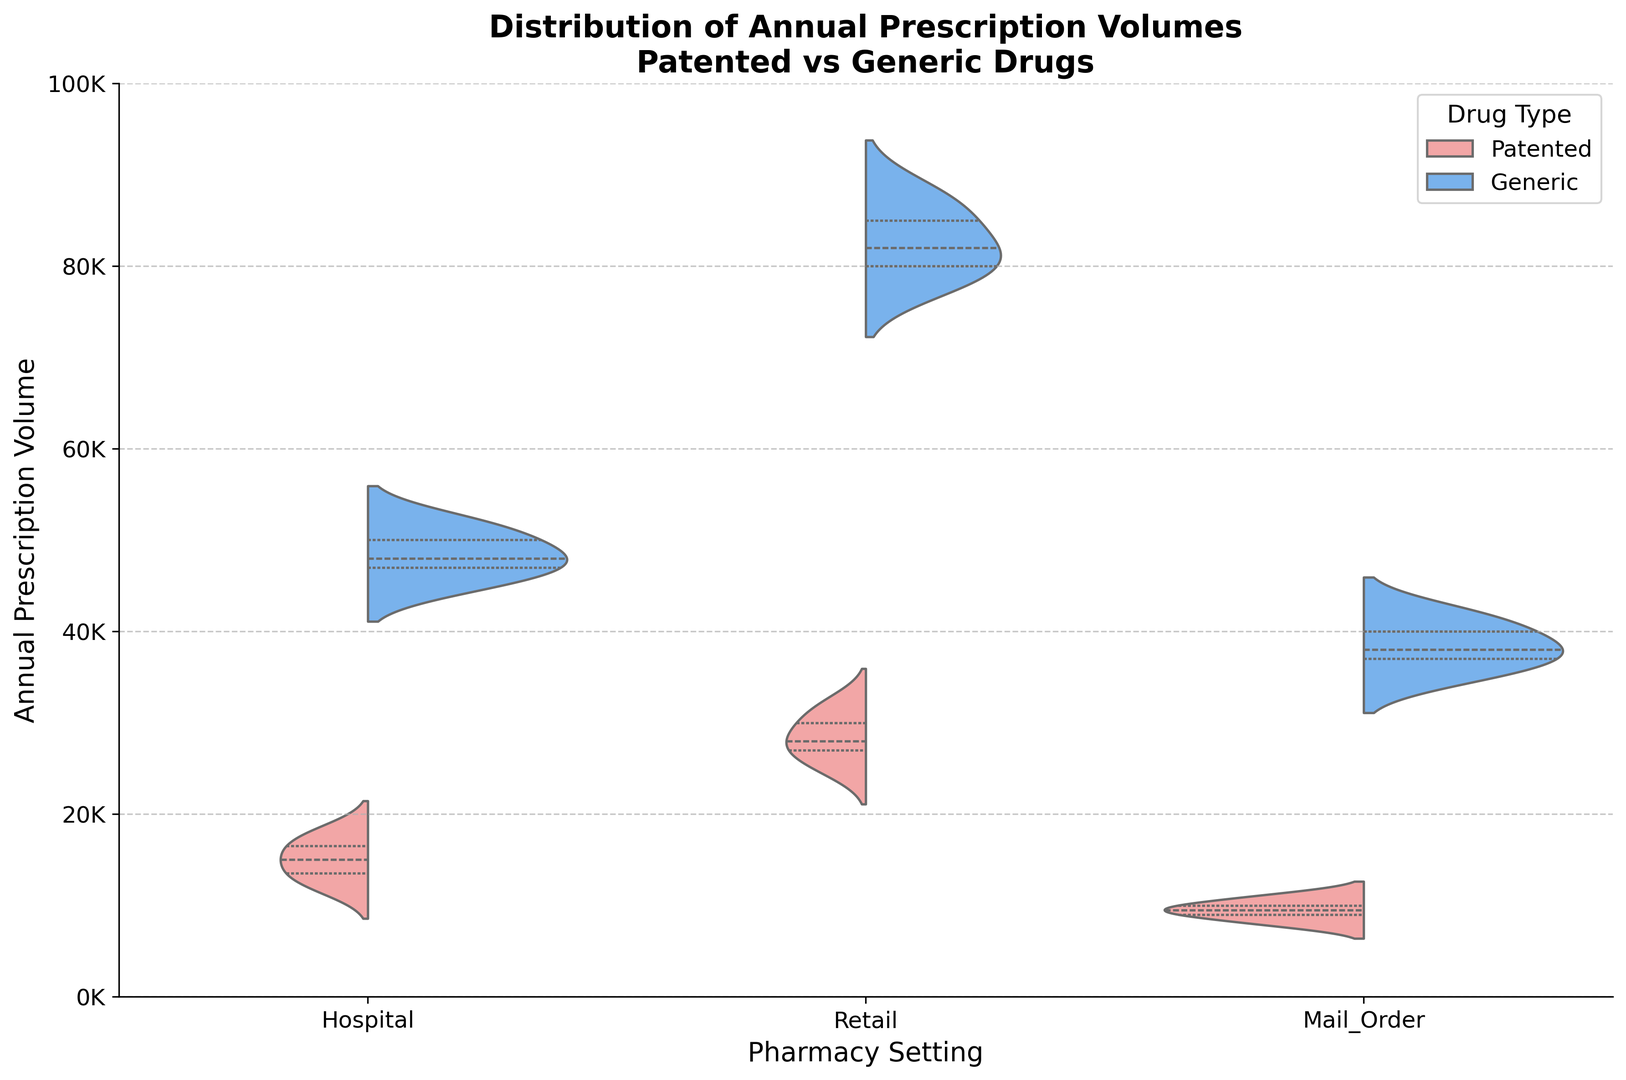What's the average annual prescription volume for patented drugs in retail settings? We observe that the annual prescription volumes for patented drugs in retail settings are 25000, 30000, 28000, 32000, and 27000. Adding them together gives 142000. Dividing by the number of data points (5), the average is 142000 / 5 = 28400
Answer: 28400 Which pharmacy setting has the highest median annual prescription volume for generic drugs? We compare the medians of the datasets for hospital, retail, and mail order pharmacy settings for generic drugs. The highest median is observed at retail settings.
Answer: Retail How does the average annual prescription volume for patented drugs compare between hospital and mail order settings? The average for hospital settings is calculated from (12000 + 15000 + 18000 + 13500 + 16500) / 5 = 15000. For mail order, it is (8000 + 10000 + 9500 + 11000 + 9000) / 5 = 9500. Therefore, the hospital setting has a higher average.
Answer: Hospital has a higher average What's the difference in the median annual prescription volume between patented and generic drugs in hospital settings? We find the median of patented drugs in hospital settings, which is 15000 (middle value of sorted data). For generic drugs, it's 48000 (middle value of sorted data). The difference is 48000 - 15000 = 33000.
Answer: 33000 Which pharmacy setting shows the greatest variability in annual prescription volumes for patented drugs? The spread of the data, as seen from the width of the violins, is greatest in retail settings for patented drugs.
Answer: Retail Compare the highest quartile of annual prescription volumes for patented drugs and generic drugs in the retail setting. Who has the higher value? The highest quartile values can be seen at the top of the violins in the retail setting. The upper values of generic drugs are higher than those of patented drugs.
Answer: Generic drugs have higher values In which pharmacy setting is the annual prescription volume for patented drugs the most evenly distributed? We observe the shape of the violins for patented drugs. The distribution in hospital settings looks the most evenly spread.
Answer: Hospital Which drug type generally has higher prescription volumes across all pharmacy settings? Comparing the height of the violins across all settings, it is clear that generic drugs generally have higher prescription volumes than patented drugs.
Answer: Generic drugs What's the interquartile range (IQR) for annual prescription volumes of generic drugs in mail-order settings? The IQR is the middle 50% of the data. For generic drugs in mail-order settings, this data appears between around 37000 and 40000 in the visually represented quartiles. So, IQR = 40000 - 37000 = 3000.
Answer: 3000 Which pharmacy setting shows the smallest difference in median annual prescription volumes between patented and generic drugs? The difference in medians between patented and generic drugs is smallest in the mail-order setting, visually compared across the figure.
Answer: Mail order 